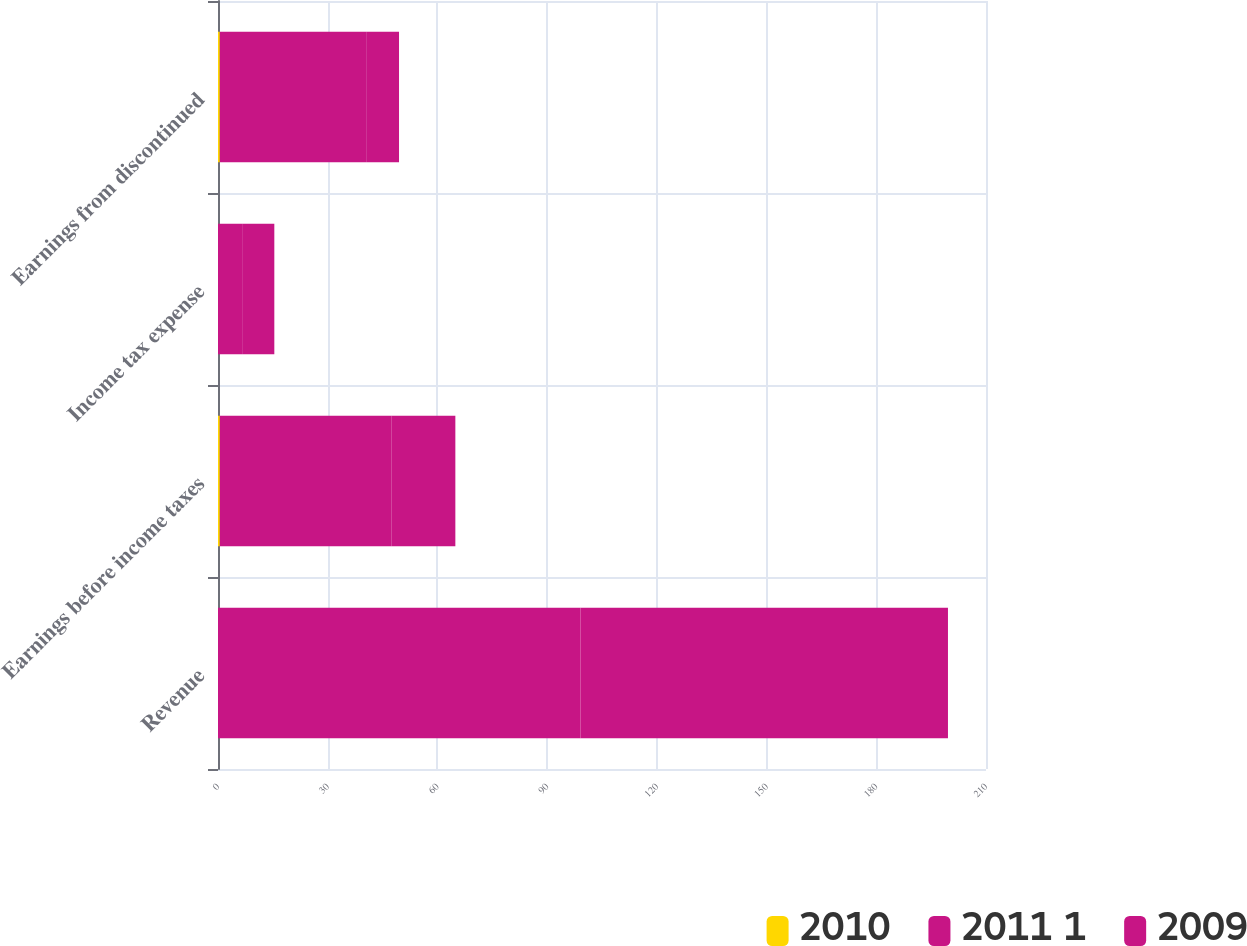Convert chart to OTSL. <chart><loc_0><loc_0><loc_500><loc_500><stacked_bar_chart><ecel><fcel>Revenue<fcel>Earnings before income taxes<fcel>Income tax expense<fcel>Earnings from discontinued<nl><fcel>2010<fcel>0<fcel>0.5<fcel>0<fcel>0.5<nl><fcel>2011 1<fcel>99.1<fcel>47<fcel>6.8<fcel>40.2<nl><fcel>2009<fcel>100.5<fcel>17.4<fcel>8.6<fcel>8.8<nl></chart> 